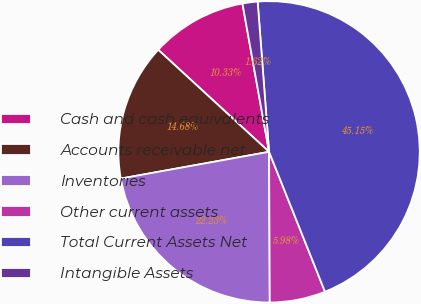Convert chart. <chart><loc_0><loc_0><loc_500><loc_500><pie_chart><fcel>Cash and cash equivalents<fcel>Accounts receivable net<fcel>Inventories<fcel>Other current assets<fcel>Total Current Assets Net<fcel>Intangible Assets<nl><fcel>10.33%<fcel>14.68%<fcel>22.23%<fcel>5.98%<fcel>45.15%<fcel>1.62%<nl></chart> 